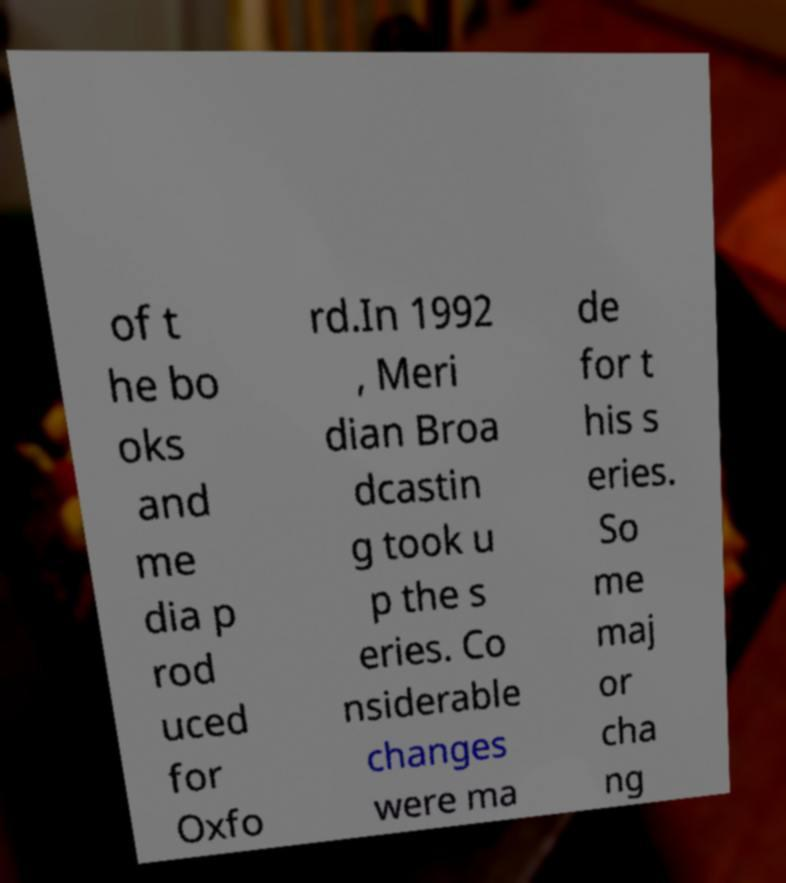Can you accurately transcribe the text from the provided image for me? of t he bo oks and me dia p rod uced for Oxfo rd.In 1992 , Meri dian Broa dcastin g took u p the s eries. Co nsiderable changes were ma de for t his s eries. So me maj or cha ng 